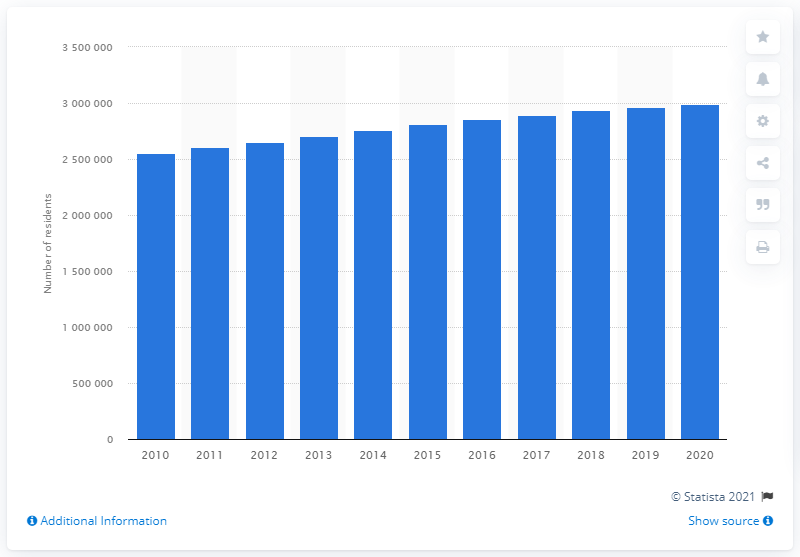Indicate a few pertinent items in this graphic. The population of the Denver-Aurora-Lakewood metropolitan area in 2020 was 296,481. In the previous year, the population of the Denver-Aurora-Lakewood metropolitan area was 293,399. 